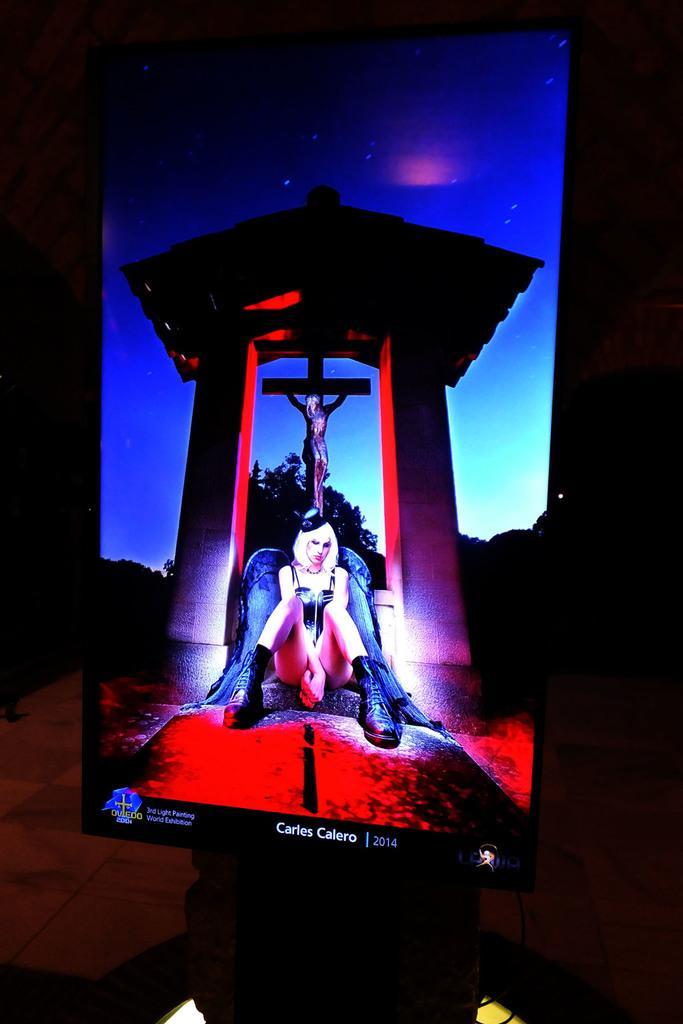Describe this image in one or two sentences. This image consists of a screen. In which there is a woman sitting. In the background, there is a cross along with trees. It is kept in a room. At the bottom, there is a floor. 